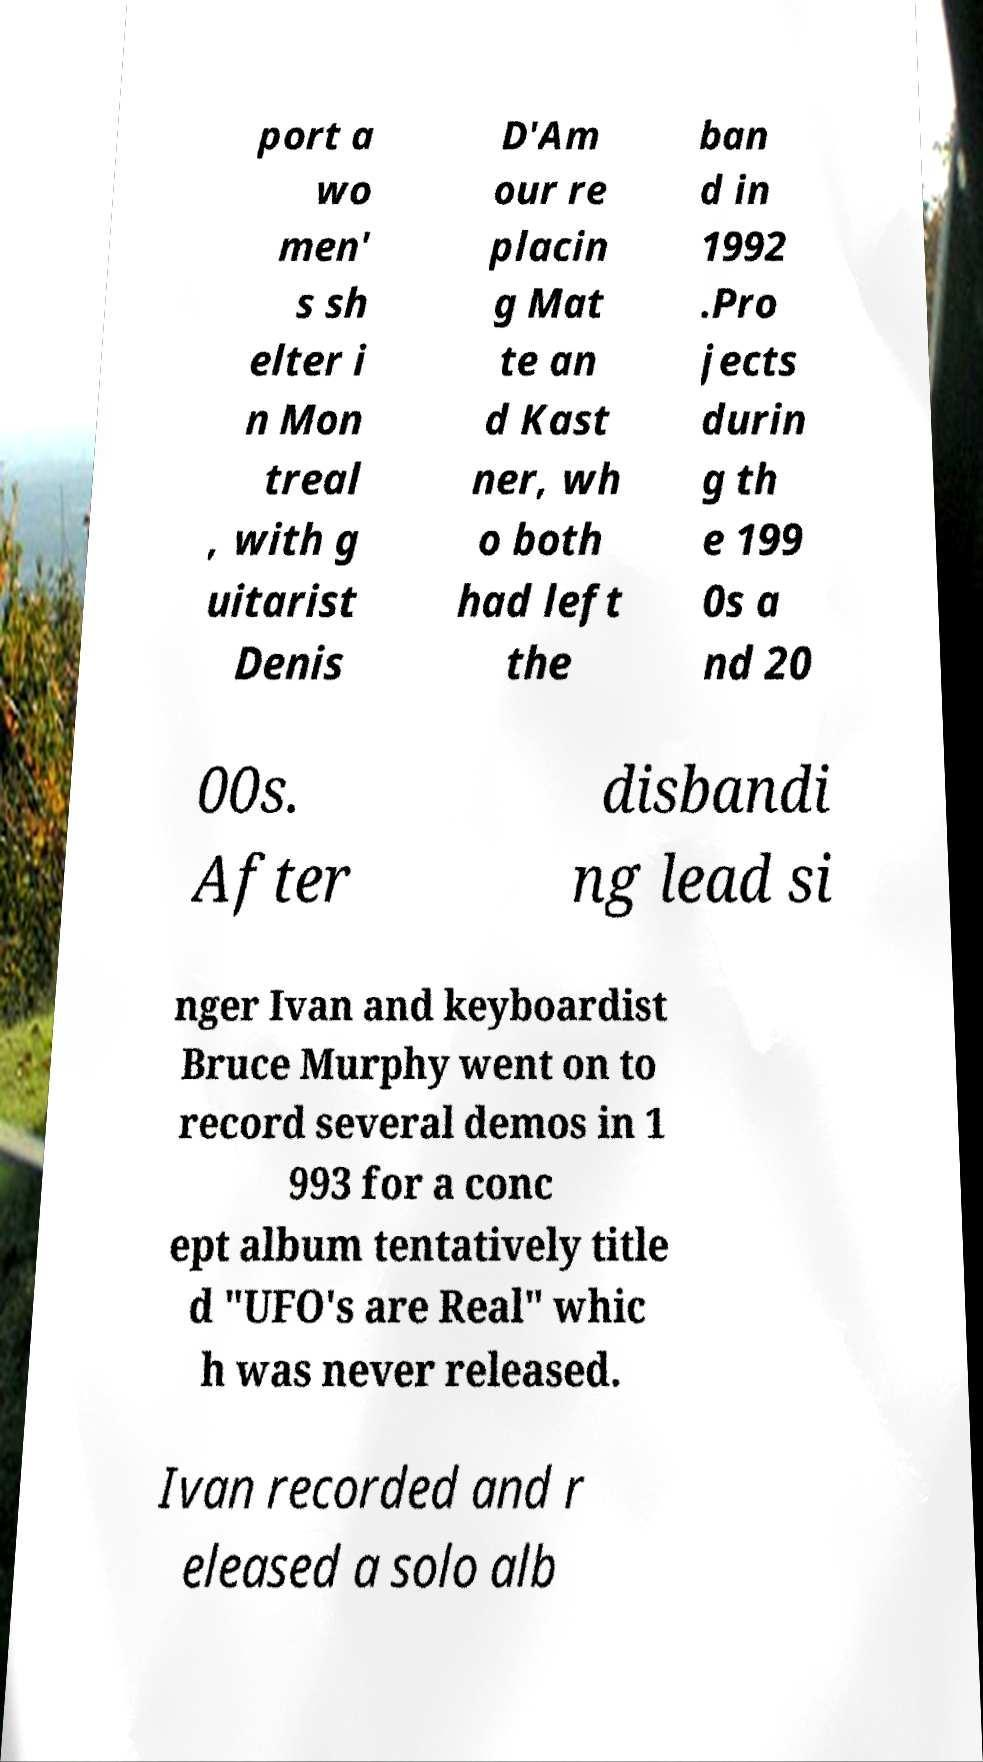I need the written content from this picture converted into text. Can you do that? port a wo men' s sh elter i n Mon treal , with g uitarist Denis D'Am our re placin g Mat te an d Kast ner, wh o both had left the ban d in 1992 .Pro jects durin g th e 199 0s a nd 20 00s. After disbandi ng lead si nger Ivan and keyboardist Bruce Murphy went on to record several demos in 1 993 for a conc ept album tentatively title d "UFO's are Real" whic h was never released. Ivan recorded and r eleased a solo alb 